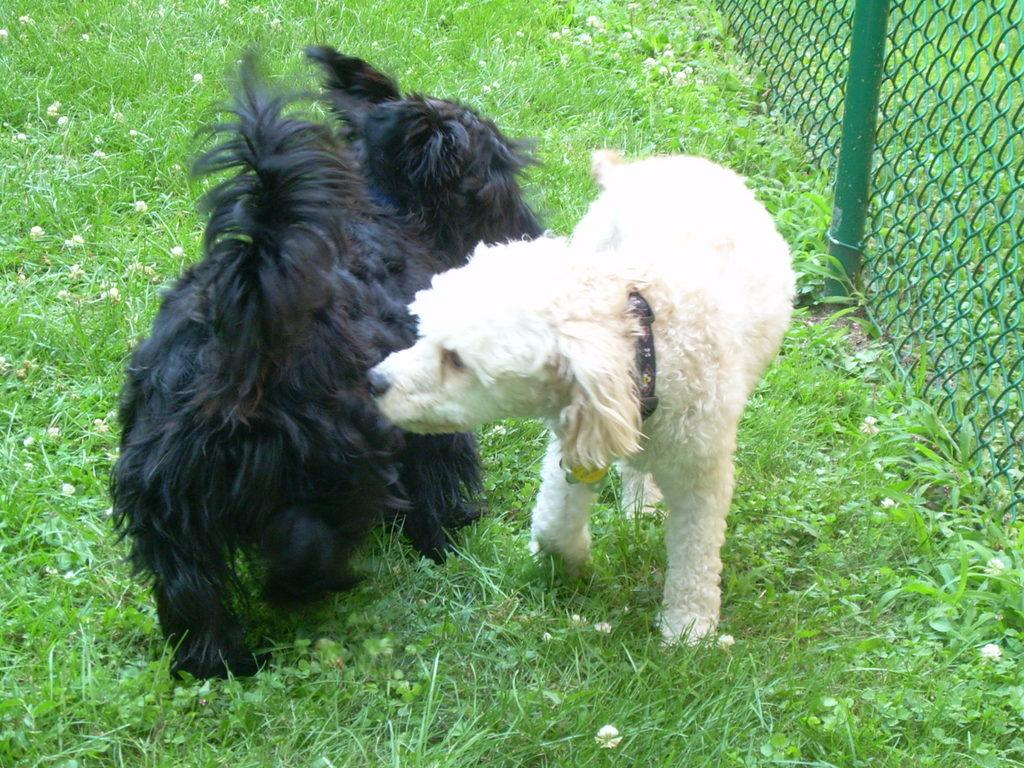How many dogs are present in the image? There are two dogs in the image. What are the colors of the dogs? One dog is white, and the other is black. What can be seen in the background of the image? There is railing in the background of the image. What is the color of the grass in the image? The grass is green in the image. What type of spoon is the pig using to eat in the image? There is no pig or spoon present in the image; it features two dogs and a background with railing. 